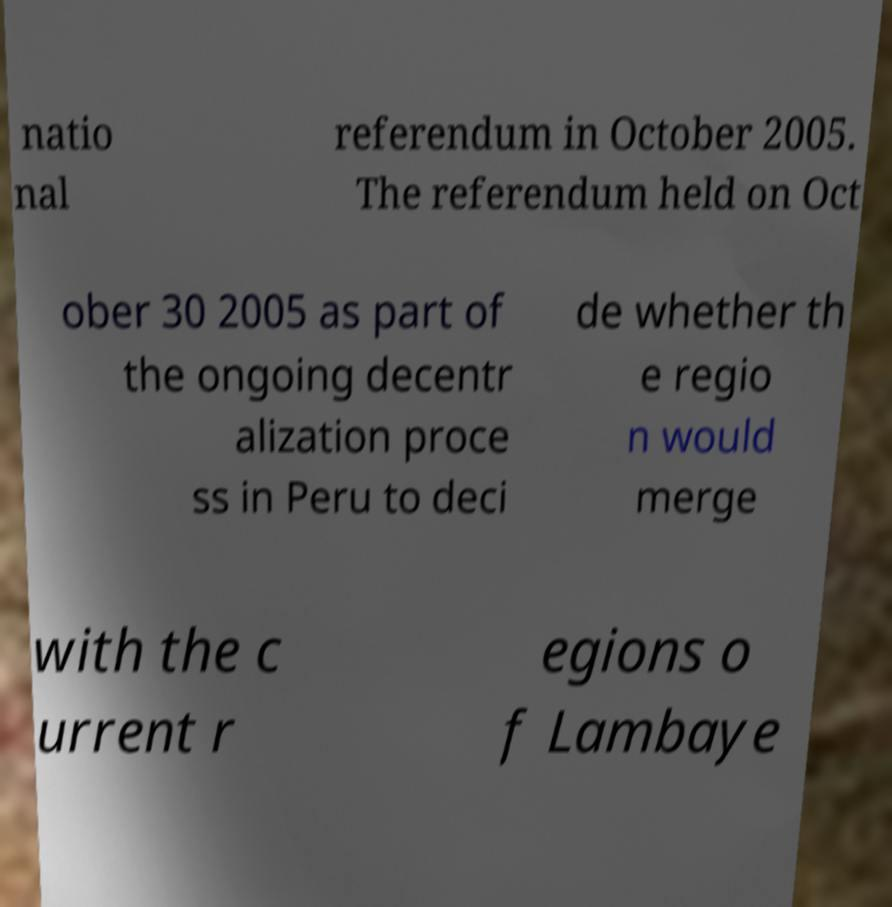There's text embedded in this image that I need extracted. Can you transcribe it verbatim? natio nal referendum in October 2005. The referendum held on Oct ober 30 2005 as part of the ongoing decentr alization proce ss in Peru to deci de whether th e regio n would merge with the c urrent r egions o f Lambaye 